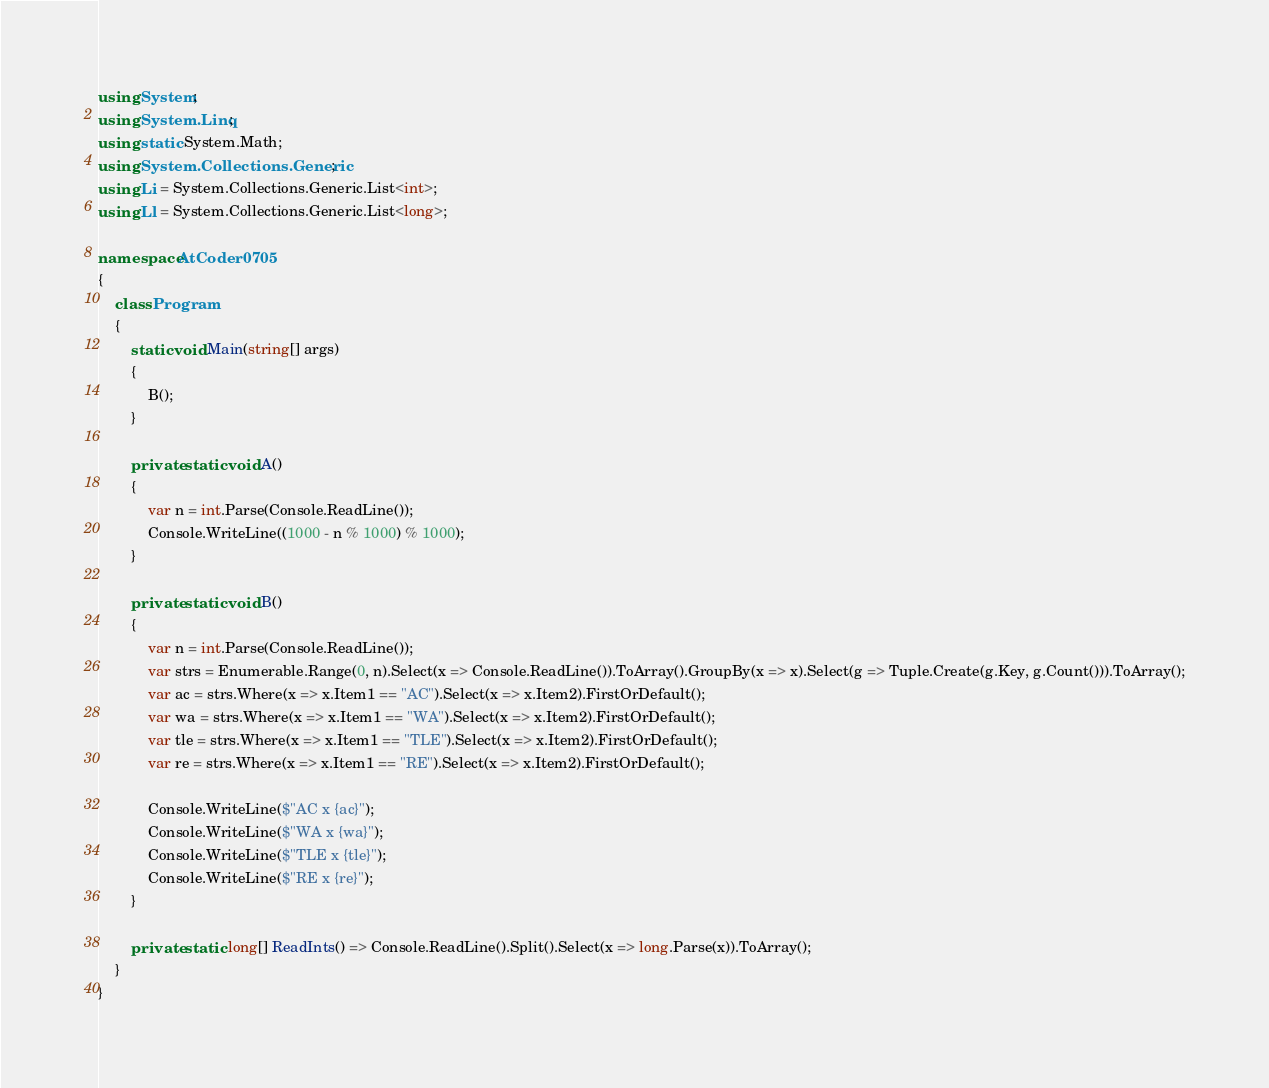Convert code to text. <code><loc_0><loc_0><loc_500><loc_500><_C#_>using System;
using System.Linq;
using static System.Math;
using System.Collections.Generic;
using Li = System.Collections.Generic.List<int>;
using Ll = System.Collections.Generic.List<long>;

namespace AtCoder0705
{
	class Program
	{
		static void Main(string[] args)
		{
			B();
		}

		private static void A()
		{
			var n = int.Parse(Console.ReadLine());
			Console.WriteLine((1000 - n % 1000) % 1000);
		}

		private static void B()
		{
			var n = int.Parse(Console.ReadLine());
			var strs = Enumerable.Range(0, n).Select(x => Console.ReadLine()).ToArray().GroupBy(x => x).Select(g => Tuple.Create(g.Key, g.Count())).ToArray();
			var ac = strs.Where(x => x.Item1 == "AC").Select(x => x.Item2).FirstOrDefault();
			var wa = strs.Where(x => x.Item1 == "WA").Select(x => x.Item2).FirstOrDefault();
			var tle = strs.Where(x => x.Item1 == "TLE").Select(x => x.Item2).FirstOrDefault();
			var re = strs.Where(x => x.Item1 == "RE").Select(x => x.Item2).FirstOrDefault();

			Console.WriteLine($"AC x {ac}");
			Console.WriteLine($"WA x {wa}");
			Console.WriteLine($"TLE x {tle}");
			Console.WriteLine($"RE x {re}");
		}

		private static long[] ReadInts() => Console.ReadLine().Split().Select(x => long.Parse(x)).ToArray();
	}
}
</code> 